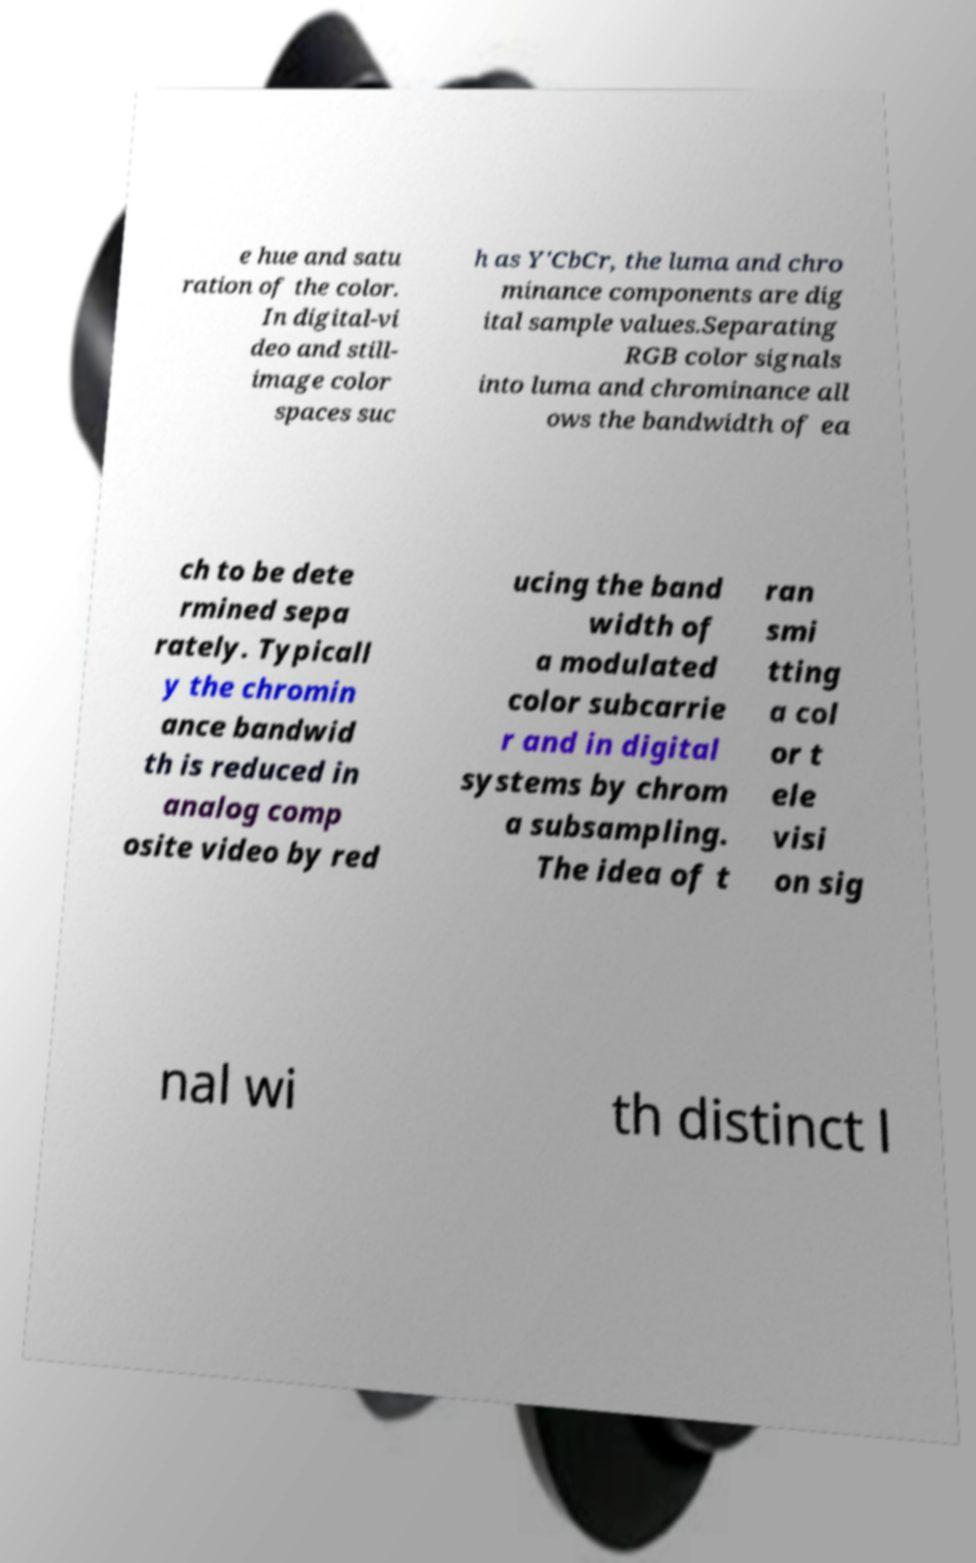Can you read and provide the text displayed in the image?This photo seems to have some interesting text. Can you extract and type it out for me? e hue and satu ration of the color. In digital-vi deo and still- image color spaces suc h as Y′CbCr, the luma and chro minance components are dig ital sample values.Separating RGB color signals into luma and chrominance all ows the bandwidth of ea ch to be dete rmined sepa rately. Typicall y the chromin ance bandwid th is reduced in analog comp osite video by red ucing the band width of a modulated color subcarrie r and in digital systems by chrom a subsampling. The idea of t ran smi tting a col or t ele visi on sig nal wi th distinct l 